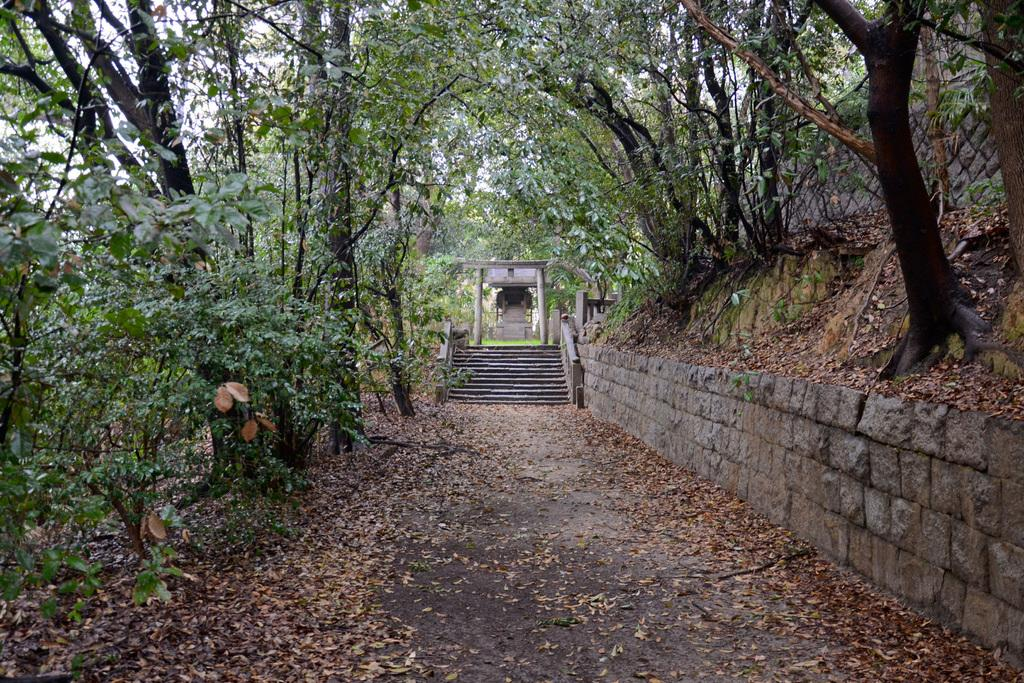What is the main feature of the image? There is a road in the image. What can be found near a wall in the image? Dry leaves are near a wall in the image. What is located on the right side of the image? There are trees on a hill on the right side of the image. What architectural feature is visible in the background of the image? There are steps in the background of the image. What type of natural environment is visible in the background of the image? Trees and the sky are visible in the background of the image. What type of punishment is being administered to the team in the image? There is no team or punishment present in the image. 